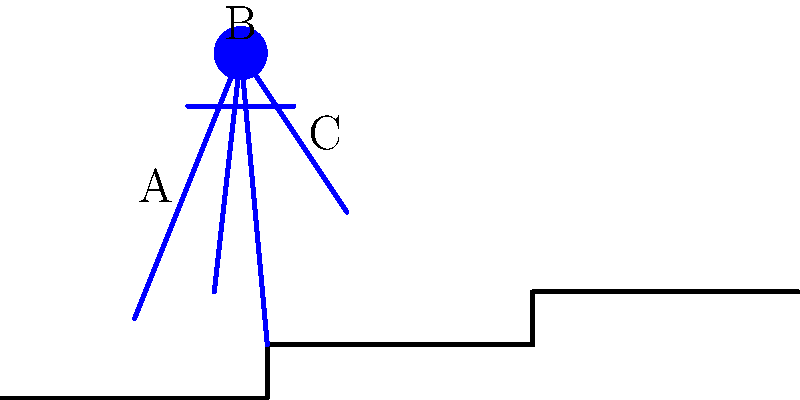In the gait analysis of a person walking up church steps, consider the stick figure representation above. If point B represents the head, what is the primary difference in the biomechanics of this upward movement compared to walking on level ground? Focus on the position of the center of mass (COM) relative to the base of support. To understand the biomechanics of walking up steps compared to level ground:

1. Center of Mass (COM) position:
   - On level ground: The COM oscillates slightly but remains relatively stable.
   - On steps: The COM must be raised significantly with each step.

2. Base of Support (BOS):
   - On level ground: The BOS shifts smoothly from one foot to the other.
   - On steps: The BOS is often momentarily reduced to one foot during the step-up motion.

3. Energy expenditure:
   - Walking up steps requires more energy to overcome gravity and raise the COM.

4. Knee and hip flexion:
   - Greater flexion is needed to lift the leg higher for each step.

5. Forward lean:
   - The body typically leans forward more to maintain balance and assist in the upward motion.

6. Arm movement:
   - Arms may be used more actively for balance and to assist in the upward motion.

The primary difference is that the COM must be raised higher relative to the BOS with each step, requiring more energy and balance control. This is evident in the figure where point B (the head, representing the approximate location of the COM) is raised significantly above the previous step level.
Answer: Vertical displacement of COM relative to BOS 